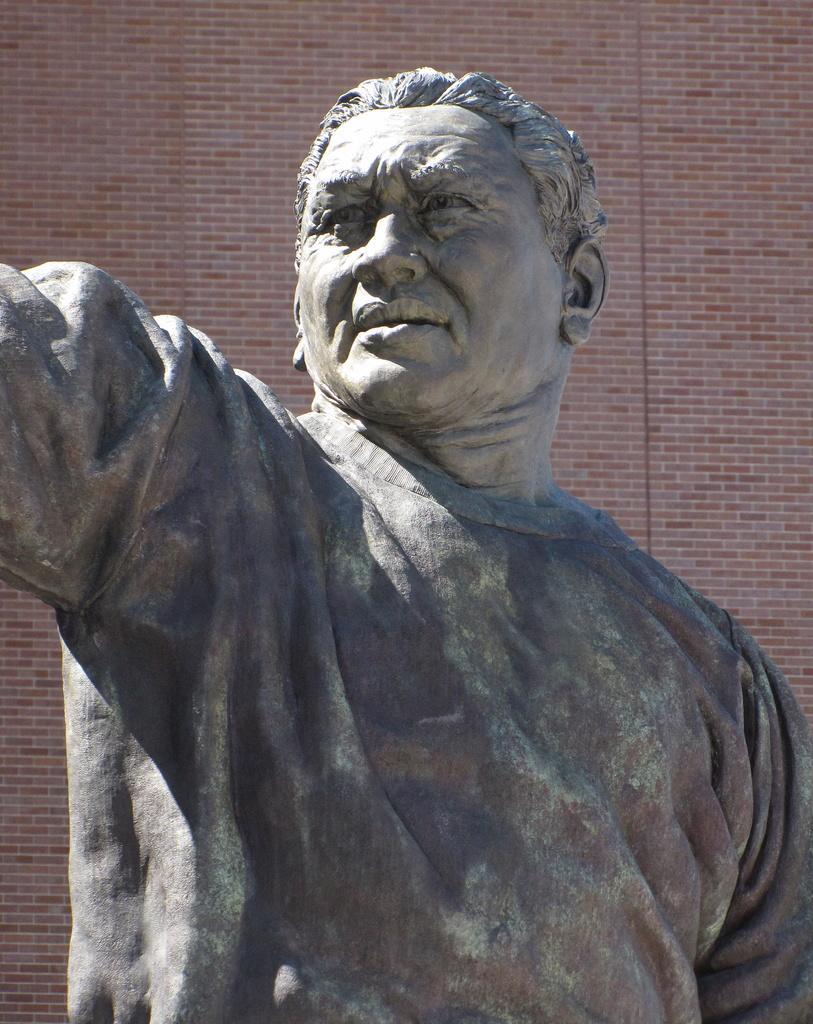In one or two sentences, can you explain what this image depicts? In this image we can see a statue, behind brick wall is there. 